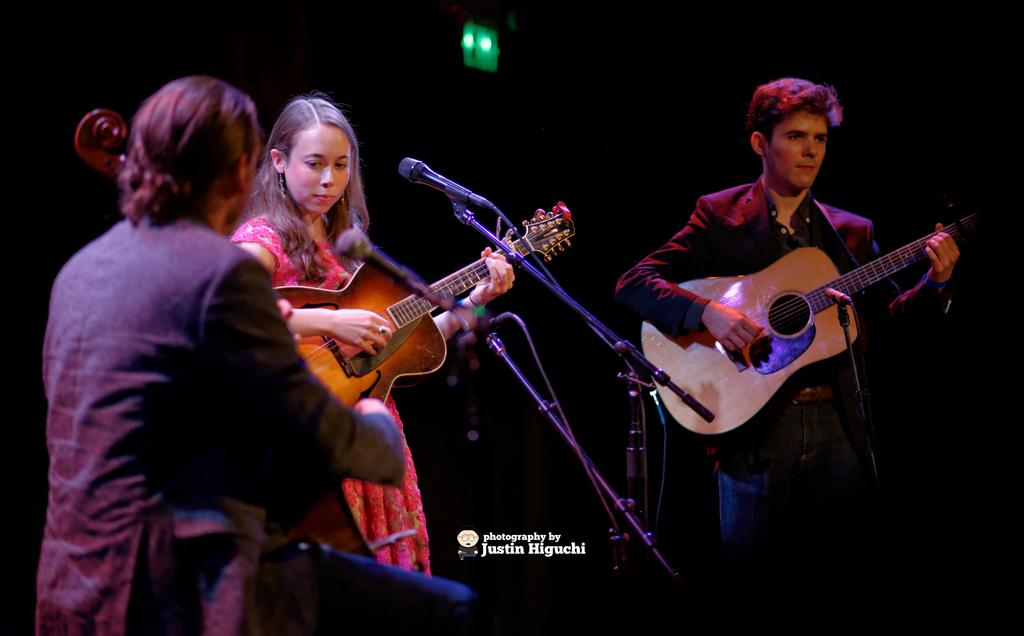How many people are in the image? There are three people in the image: two men and one lady. What are the men doing in the image? The men are playing guitars. What is the lady wearing in the image? The lady is wearing a pink frock. What is the lady doing in the image? The lady is playing a guitar. What equipment is present for amplifying sound in the image? There are two microphones with stands in the image. What color is the jacket worn by the man on the right side? The man on the right side is wearing a black jacket. How many spiders are crawling on the guitar strings in the image? There are no spiders present in the image; the men are playing guitars without any spiders on the strings. What type of lift is available for the lady to reach the microphone in the image? There is no lift present in the image, and the lady is already playing a guitar without needing assistance to reach the microphone. 